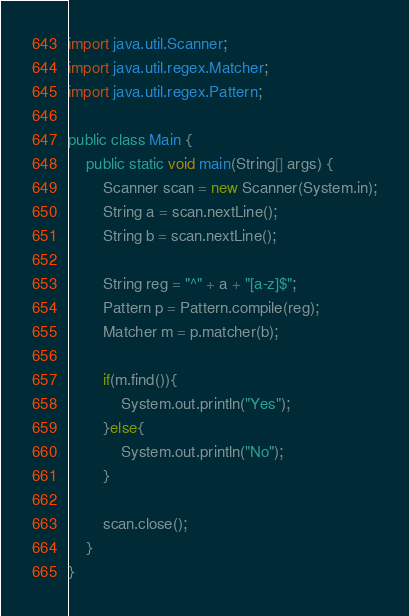Convert code to text. <code><loc_0><loc_0><loc_500><loc_500><_Java_>import java.util.Scanner;
import java.util.regex.Matcher;
import java.util.regex.Pattern; 

public class Main {
    public static void main(String[] args) {
        Scanner scan = new Scanner(System.in);
        String a = scan.nextLine();
        String b = scan.nextLine();

        String reg = "^" + a + "[a-z]$";
        Pattern p = Pattern.compile(reg);
        Matcher m = p.matcher(b);

        if(m.find()){
            System.out.println("Yes");
        }else{
            System.out.println("No");
        }

        scan.close();
    }
}</code> 